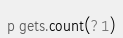Convert code to text. <code><loc_0><loc_0><loc_500><loc_500><_Ruby_>p gets.count(?1)</code> 